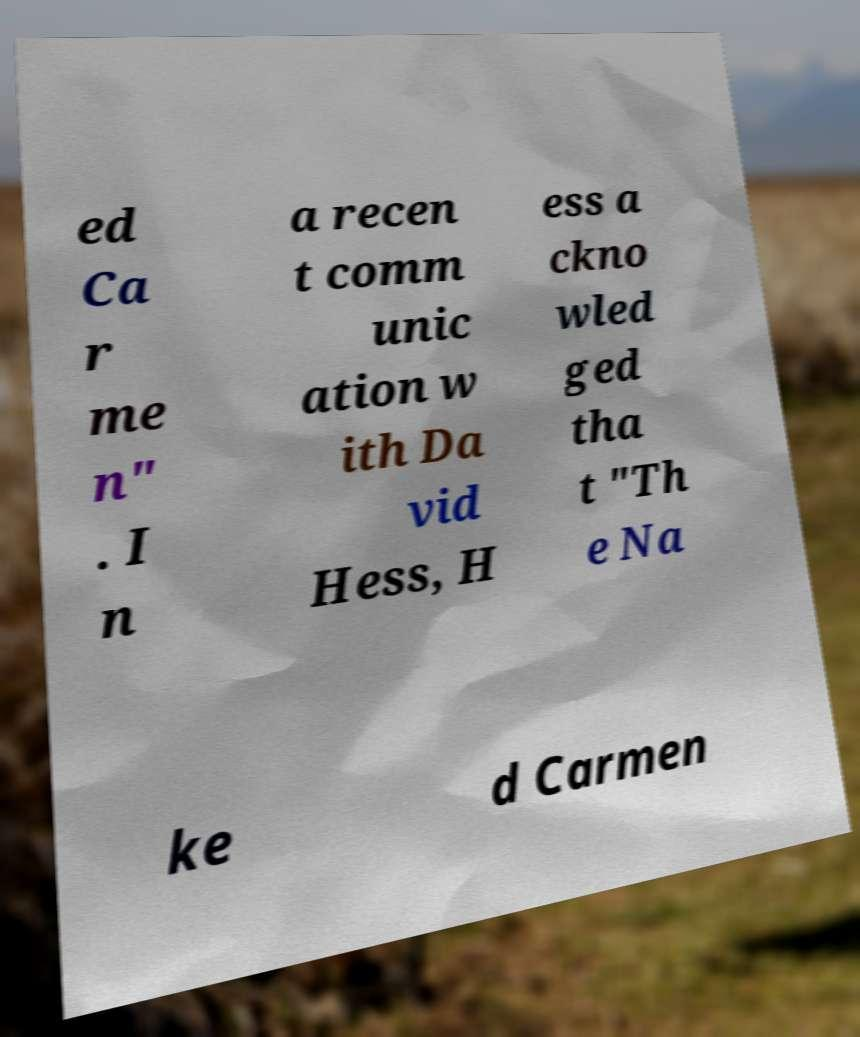Could you extract and type out the text from this image? ed Ca r me n" . I n a recen t comm unic ation w ith Da vid Hess, H ess a ckno wled ged tha t "Th e Na ke d Carmen 